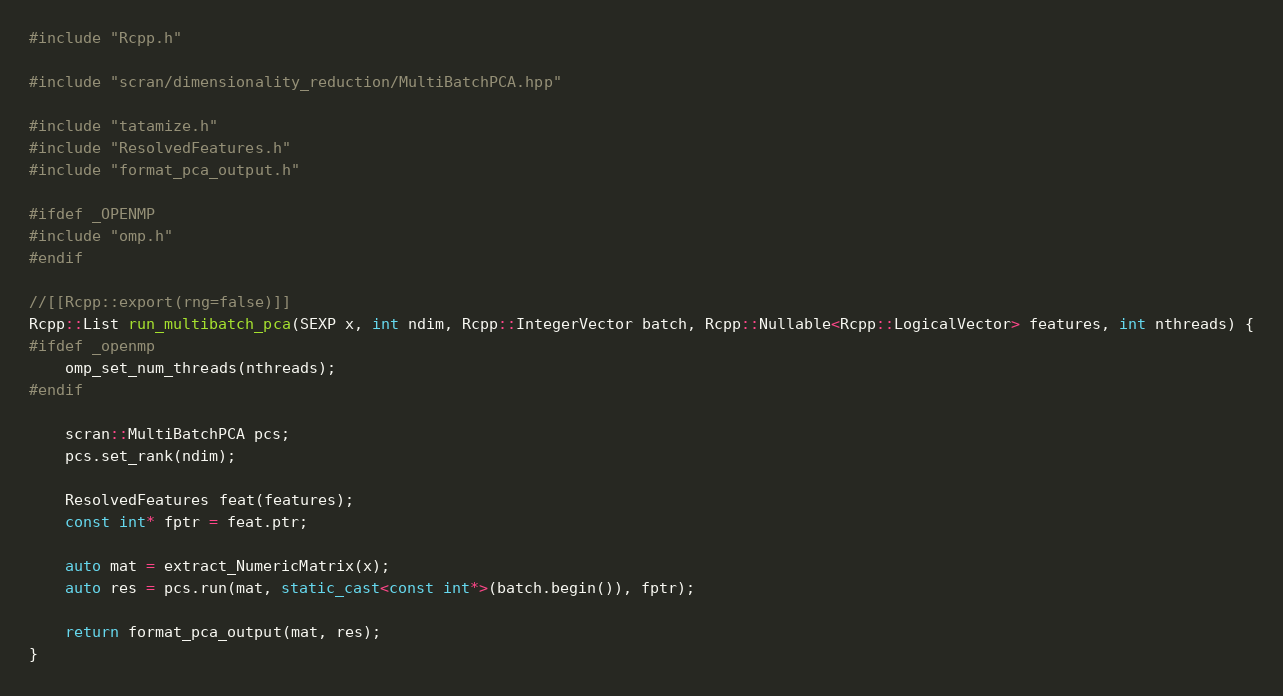<code> <loc_0><loc_0><loc_500><loc_500><_C++_>#include "Rcpp.h"

#include "scran/dimensionality_reduction/MultiBatchPCA.hpp"

#include "tatamize.h"
#include "ResolvedFeatures.h"
#include "format_pca_output.h"

#ifdef _OPENMP
#include "omp.h"
#endif

//[[Rcpp::export(rng=false)]]
Rcpp::List run_multibatch_pca(SEXP x, int ndim, Rcpp::IntegerVector batch, Rcpp::Nullable<Rcpp::LogicalVector> features, int nthreads) {
#ifdef _openmp
    omp_set_num_threads(nthreads);
#endif

    scran::MultiBatchPCA pcs;
    pcs.set_rank(ndim);

    ResolvedFeatures feat(features);
    const int* fptr = feat.ptr;

    auto mat = extract_NumericMatrix(x);
    auto res = pcs.run(mat, static_cast<const int*>(batch.begin()), fptr);

    return format_pca_output(mat, res);
}
</code> 